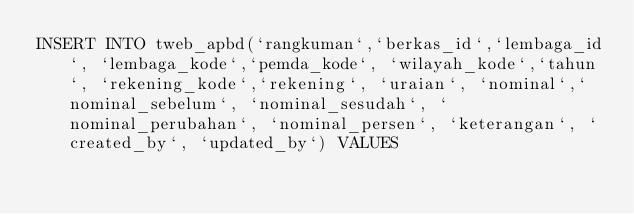Convert code to text. <code><loc_0><loc_0><loc_500><loc_500><_SQL_>INSERT INTO tweb_apbd(`rangkuman`,`berkas_id`,`lembaga_id`, `lembaga_kode`,`pemda_kode`, `wilayah_kode`,`tahun`, `rekening_kode`,`rekening`, `uraian`, `nominal`,`nominal_sebelum`, `nominal_sesudah`, `nominal_perubahan`, `nominal_persen`, `keterangan`, `created_by`, `updated_by`) VALUES </code> 